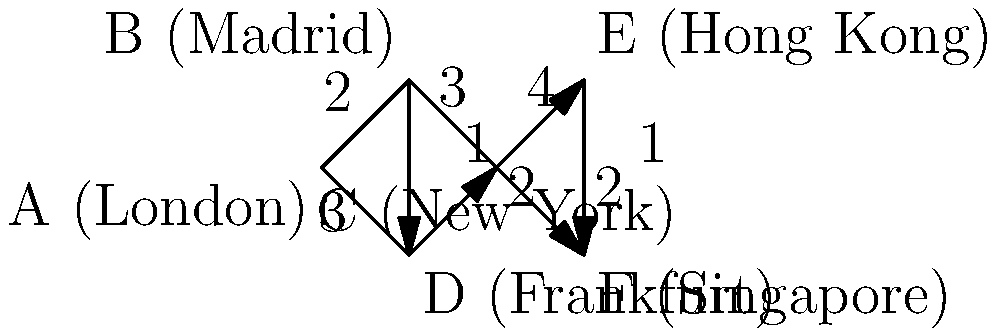In the network representing Santander International's global branches, what is the shortest path from London (A) to Hong Kong (E), and what is its total distance? To find the shortest path from London (A) to Hong Kong (E), we need to consider all possible paths and their total distances. Let's examine the options:

1. A → B → C → E:
   Distance = 2 + 3 + 4 = 9

2. A → D → C → E:
   Distance = 3 + 2 + 4 = 9

3. A → B → D → C → E:
   Distance = 2 + 1 + 2 + 4 = 9

4. A → D → B → C → E:
   Distance = 3 + 1 + 3 + 4 = 11

The shortest paths are:
1. A → B → C → E
2. A → D → C → E
3. A → B → D → C → E

All of these paths have a total distance of 9.

Among these, the path with the fewest nodes is A → B → C → E, which we can consider as the optimal shortest path.
Answer: A → B → C → E, with a total distance of 9. 